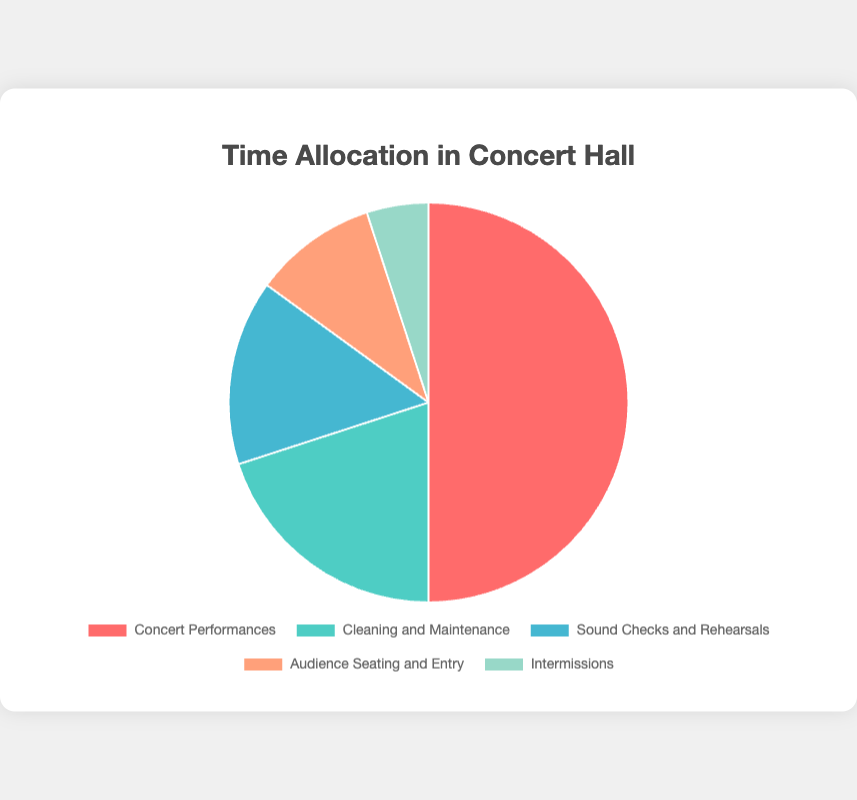What activity takes up the most time allocation in the concert hall? The slice in the pie chart representing "Concert Performances" has the largest area, indicating it takes up the most time allocation.
Answer: Concert Performances How much more time is allocated to "Concert Performances" compared to "Cleaning and Maintenance"? "Concert Performances" take up 50% of the time, while "Cleaning and Maintenance" takes up 20%. The difference between these two percentages is 50% - 20%.
Answer: 30% Which activity occupies the smallest time allocation and what is its percentage? The smallest slice in the pie chart represents "Intermissions," which takes up 5% of the total time allocation.
Answer: Intermissions, 5% What is the total time allocation percentage for all activities excluding "Concert Performances"? Add the time allocations for "Cleaning and Maintenance" (20%), "Sound Checks and Rehearsals" (15%), "Audience Seating and Entry" (10%), and "Intermissions" (5%). The sum is 20% + 15% + 10% + 5%.
Answer: 50% How much more time is allocated to "Sound Checks and Rehearsals" compared to "Intermissions"? "Sound Checks and Rehearsals" takes up 15% of the time, while "Intermissions" takes up 5%. The difference between these two percentages is 15% - 5%.
Answer: 10% What is the combined time allocation percentage for "Sound Checks and Rehearsals" and "Audience Seating and Entry"? Add the time allocations for "Sound Checks and Rehearsals" (15%) and "Audience Seating and Entry" (10%). The sum is 15% + 10%.
Answer: 25% Which activity uses more time: "Audience Seating and Entry" or "Cleaning and Maintenance"? Comparing the slices, "Cleaning and Maintenance" has a larger slice (20%) than "Audience Seating and Entry" (10%).
Answer: Cleaning and Maintenance What is the percentage difference between "Cleaning and Maintenance" and "Sound Checks and Rehearsals"? "Cleaning and Maintenance" occupies 20% while "Sound Checks and Rehearsals" occupy 15%. The difference is 20% - 15%.
Answer: 5% Name all the activities that take up more than 10% of the total time allocation. By examining the pie chart, the activities with more than 10% time allocation are "Concert Performances," "Cleaning and Maintenance," and "Sound Checks and Rehearsals."
Answer: Concert Performances, Cleaning and Maintenance, Sound Checks and Rehearsals 